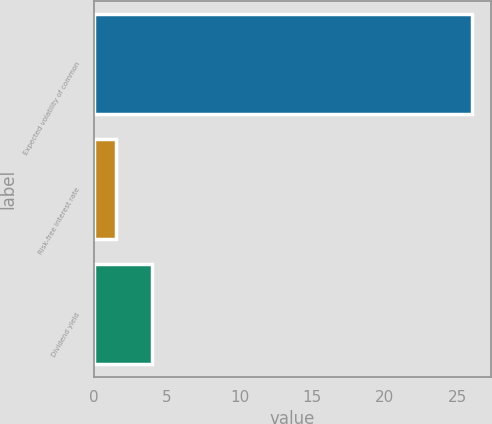<chart> <loc_0><loc_0><loc_500><loc_500><bar_chart><fcel>Expected volatility of common<fcel>Risk-free interest rate<fcel>Dividend yield<nl><fcel>26<fcel>1.5<fcel>3.95<nl></chart> 